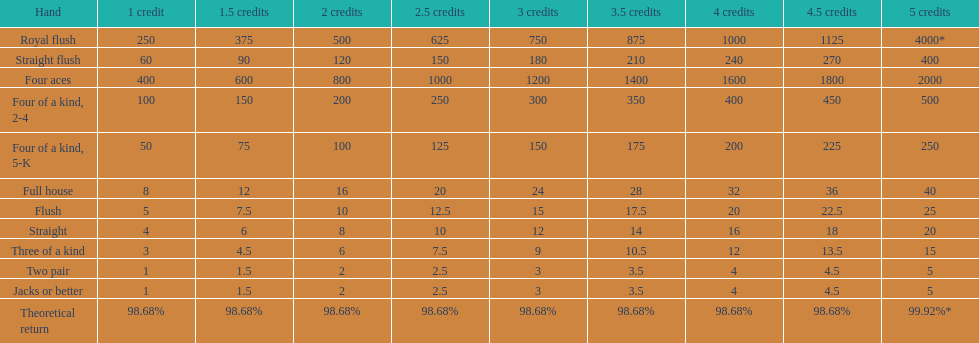Is four 5s worth more or less than four 2s? Less. 